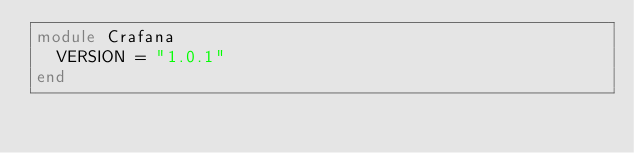Convert code to text. <code><loc_0><loc_0><loc_500><loc_500><_Crystal_>module Crafana
  VERSION = "1.0.1"
end
</code> 